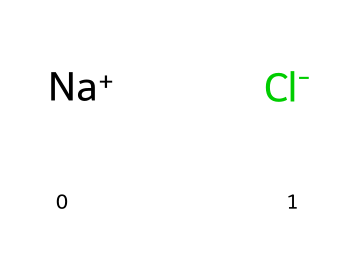how many atoms are in sodium chloride? Sodium chloride consists of one sodium atom and one chlorine atom, totaling two atoms in the compound.
Answer: 2 what type of bond exists in sodium chloride? Sodium chloride features an ionic bond formed by the transfer of an electron from sodium to chlorine, resulting in a positively charged sodium ion and a negatively charged chloride ion.
Answer: ionic bond what are the charges of the sodium and chlorine ions? In sodium chloride, the sodium ion carries a positive charge (Na+) and the chloride ion carries a negative charge (Cl-).
Answer: positive and negative which element is a halogen in the composition of sodium chloride? The sodium chloride compound contains chlorine, which is classified as a halogen due to its group in the periodic table, known for its reactivity and formation of salts with metals.
Answer: chlorine why is sodium chloride essential for life? Sodium chloride is critical for maintaining electrolyte balance, supporting nerve function, and regulating hydration in living organisms, thus playing a vital role in numerous biological processes.
Answer: electrolyte balance how does the oxidation state of sodium compare to that of chlorine in sodium chloride? Sodium has an oxidation state of +1 due to losing an electron, while chlorine has an oxidation state of -1 due to gaining that electron, resulting in their ionic bond.
Answer: +1 and -1 